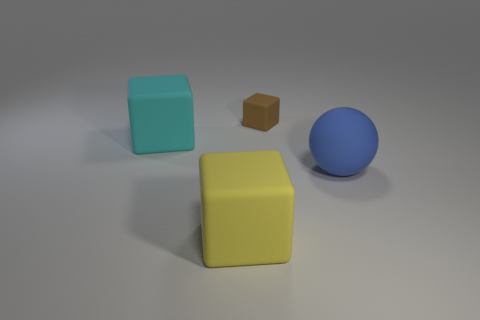Subtract all big rubber cubes. How many cubes are left? 1 Subtract all blocks. How many objects are left? 1 Add 3 small red metallic cubes. How many objects exist? 7 Subtract 1 balls. How many balls are left? 0 Subtract all brown blocks. How many blocks are left? 2 Subtract all big cyan matte things. Subtract all yellow objects. How many objects are left? 2 Add 1 big yellow matte things. How many big yellow matte things are left? 2 Add 4 brown metal things. How many brown metal things exist? 4 Subtract 0 gray blocks. How many objects are left? 4 Subtract all gray blocks. Subtract all cyan cylinders. How many blocks are left? 3 